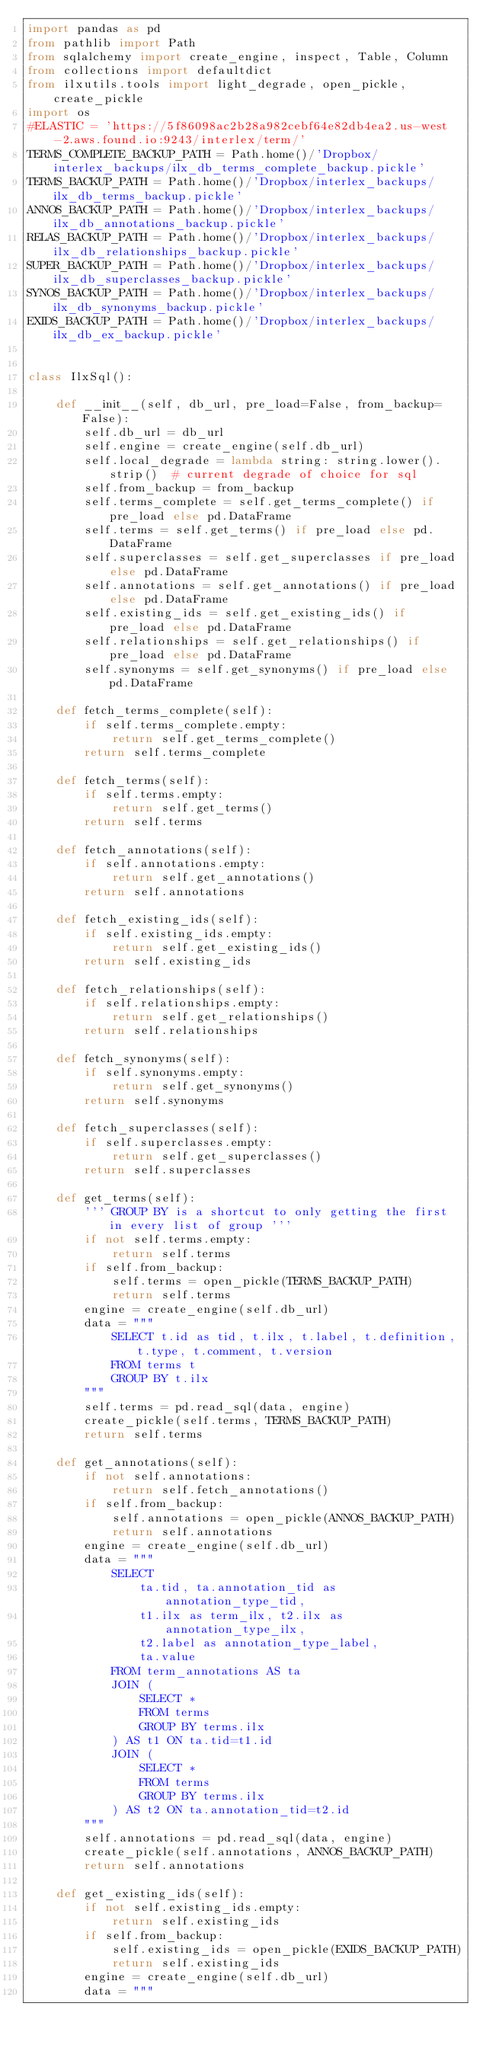<code> <loc_0><loc_0><loc_500><loc_500><_Python_>import pandas as pd
from pathlib import Path
from sqlalchemy import create_engine, inspect, Table, Column
from collections import defaultdict
from ilxutils.tools import light_degrade, open_pickle, create_pickle
import os
#ELASTIC = 'https://5f86098ac2b28a982cebf64e82db4ea2.us-west-2.aws.found.io:9243/interlex/term/'
TERMS_COMPLETE_BACKUP_PATH = Path.home()/'Dropbox/interlex_backups/ilx_db_terms_complete_backup.pickle'
TERMS_BACKUP_PATH = Path.home()/'Dropbox/interlex_backups/ilx_db_terms_backup.pickle'
ANNOS_BACKUP_PATH = Path.home()/'Dropbox/interlex_backups/ilx_db_annotations_backup.pickle'
RELAS_BACKUP_PATH = Path.home()/'Dropbox/interlex_backups/ilx_db_relationships_backup.pickle'
SUPER_BACKUP_PATH = Path.home()/'Dropbox/interlex_backups/ilx_db_superclasses_backup.pickle'
SYNOS_BACKUP_PATH = Path.home()/'Dropbox/interlex_backups/ilx_db_synonyms_backup.pickle'
EXIDS_BACKUP_PATH = Path.home()/'Dropbox/interlex_backups/ilx_db_ex_backup.pickle'


class IlxSql():

    def __init__(self, db_url, pre_load=False, from_backup=False):
        self.db_url = db_url
        self.engine = create_engine(self.db_url)
        self.local_degrade = lambda string: string.lower().strip()  # current degrade of choice for sql
        self.from_backup = from_backup
        self.terms_complete = self.get_terms_complete() if pre_load else pd.DataFrame
        self.terms = self.get_terms() if pre_load else pd.DataFrame
        self.superclasses = self.get_superclasses if pre_load else pd.DataFrame
        self.annotations = self.get_annotations() if pre_load else pd.DataFrame
        self.existing_ids = self.get_existing_ids() if pre_load else pd.DataFrame
        self.relationships = self.get_relationships() if pre_load else pd.DataFrame
        self.synonyms = self.get_synonyms() if pre_load else pd.DataFrame

    def fetch_terms_complete(self):
        if self.terms_complete.empty:
            return self.get_terms_complete()
        return self.terms_complete

    def fetch_terms(self):
        if self.terms.empty:
            return self.get_terms()
        return self.terms

    def fetch_annotations(self):
        if self.annotations.empty:
            return self.get_annotations()
        return self.annotations

    def fetch_existing_ids(self):
        if self.existing_ids.empty:
            return self.get_existing_ids()
        return self.existing_ids

    def fetch_relationships(self):
        if self.relationships.empty:
            return self.get_relationships()
        return self.relationships

    def fetch_synonyms(self):
        if self.synonyms.empty:
            return self.get_synonyms()
        return self.synonyms

    def fetch_superclasses(self):
        if self.superclasses.empty:
            return self.get_superclasses()
        return self.superclasses

    def get_terms(self):
        ''' GROUP BY is a shortcut to only getting the first in every list of group '''
        if not self.terms.empty:
            return self.terms
        if self.from_backup:
            self.terms = open_pickle(TERMS_BACKUP_PATH)
            return self.terms
        engine = create_engine(self.db_url)
        data = """
            SELECT t.id as tid, t.ilx, t.label, t.definition, t.type, t.comment, t.version
            FROM terms t
            GROUP BY t.ilx
        """
        self.terms = pd.read_sql(data, engine)
        create_pickle(self.terms, TERMS_BACKUP_PATH)
        return self.terms

    def get_annotations(self):
        if not self.annotations:
            return self.fetch_annotations()
        if self.from_backup:
            self.annotations = open_pickle(ANNOS_BACKUP_PATH)
            return self.annotations
        engine = create_engine(self.db_url)
        data = """
            SELECT
                ta.tid, ta.annotation_tid as annotation_type_tid,
                t1.ilx as term_ilx, t2.ilx as annotation_type_ilx,
                t2.label as annotation_type_label,
                ta.value
            FROM term_annotations AS ta
            JOIN (
                SELECT *
                FROM terms
                GROUP BY terms.ilx
            ) AS t1 ON ta.tid=t1.id
            JOIN (
                SELECT *
                FROM terms
                GROUP BY terms.ilx
            ) AS t2 ON ta.annotation_tid=t2.id
        """
        self.annotations = pd.read_sql(data, engine)
        create_pickle(self.annotations, ANNOS_BACKUP_PATH)
        return self.annotations

    def get_existing_ids(self):
        if not self.existing_ids.empty:
            return self.existing_ids
        if self.from_backup:
            self.existing_ids = open_pickle(EXIDS_BACKUP_PATH)
            return self.existing_ids
        engine = create_engine(self.db_url)
        data = """</code> 